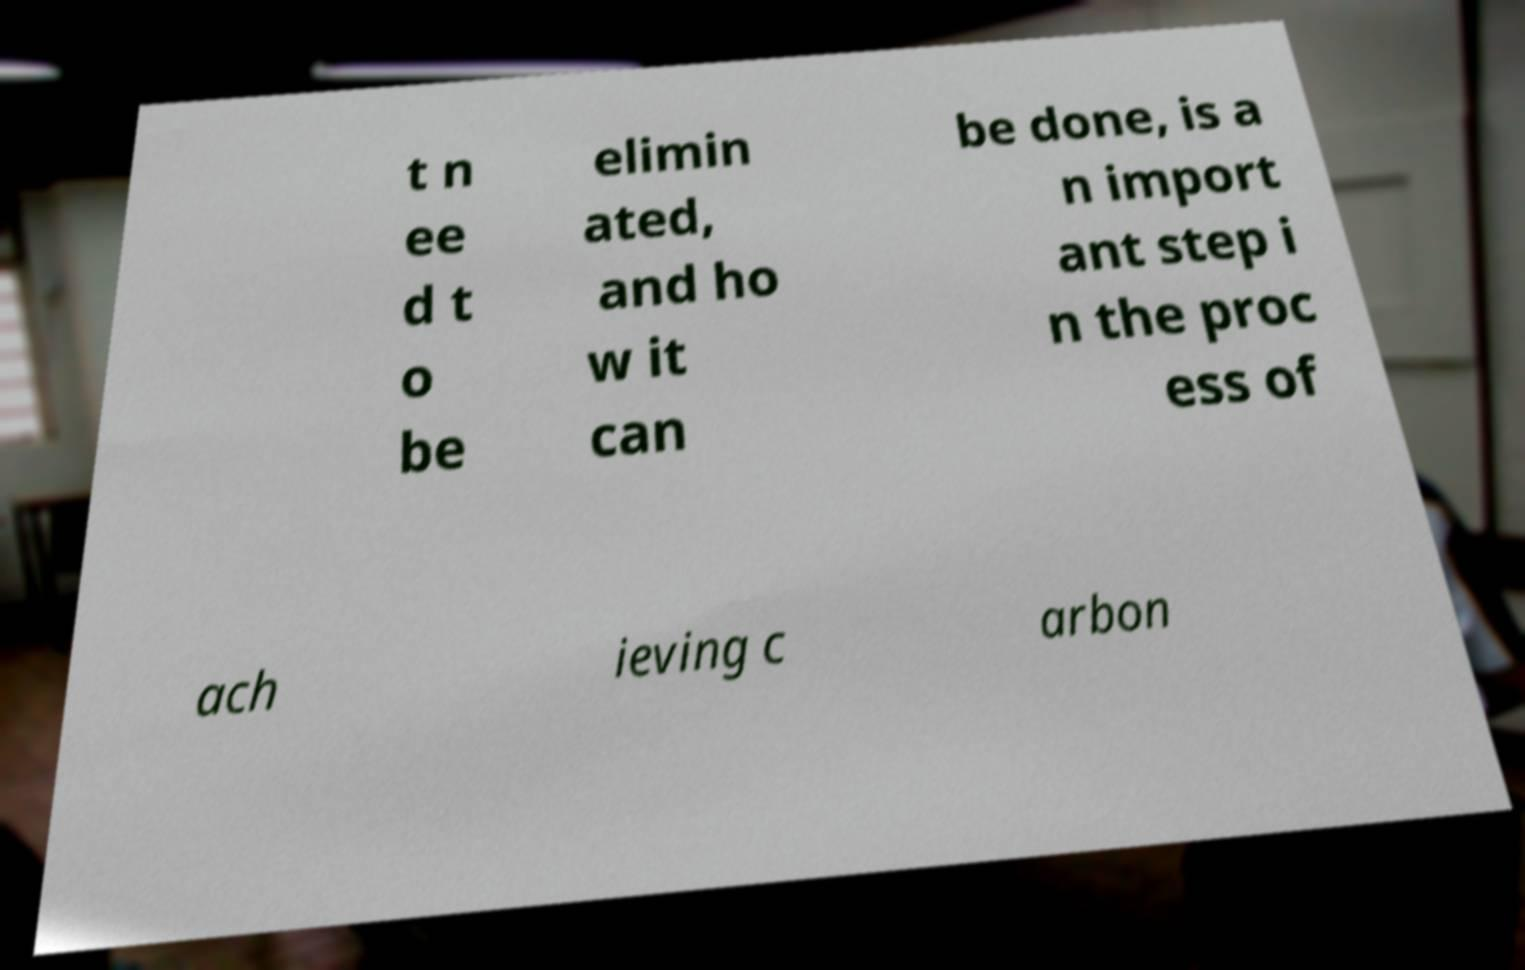What messages or text are displayed in this image? I need them in a readable, typed format. t n ee d t o be elimin ated, and ho w it can be done, is a n import ant step i n the proc ess of ach ieving c arbon 